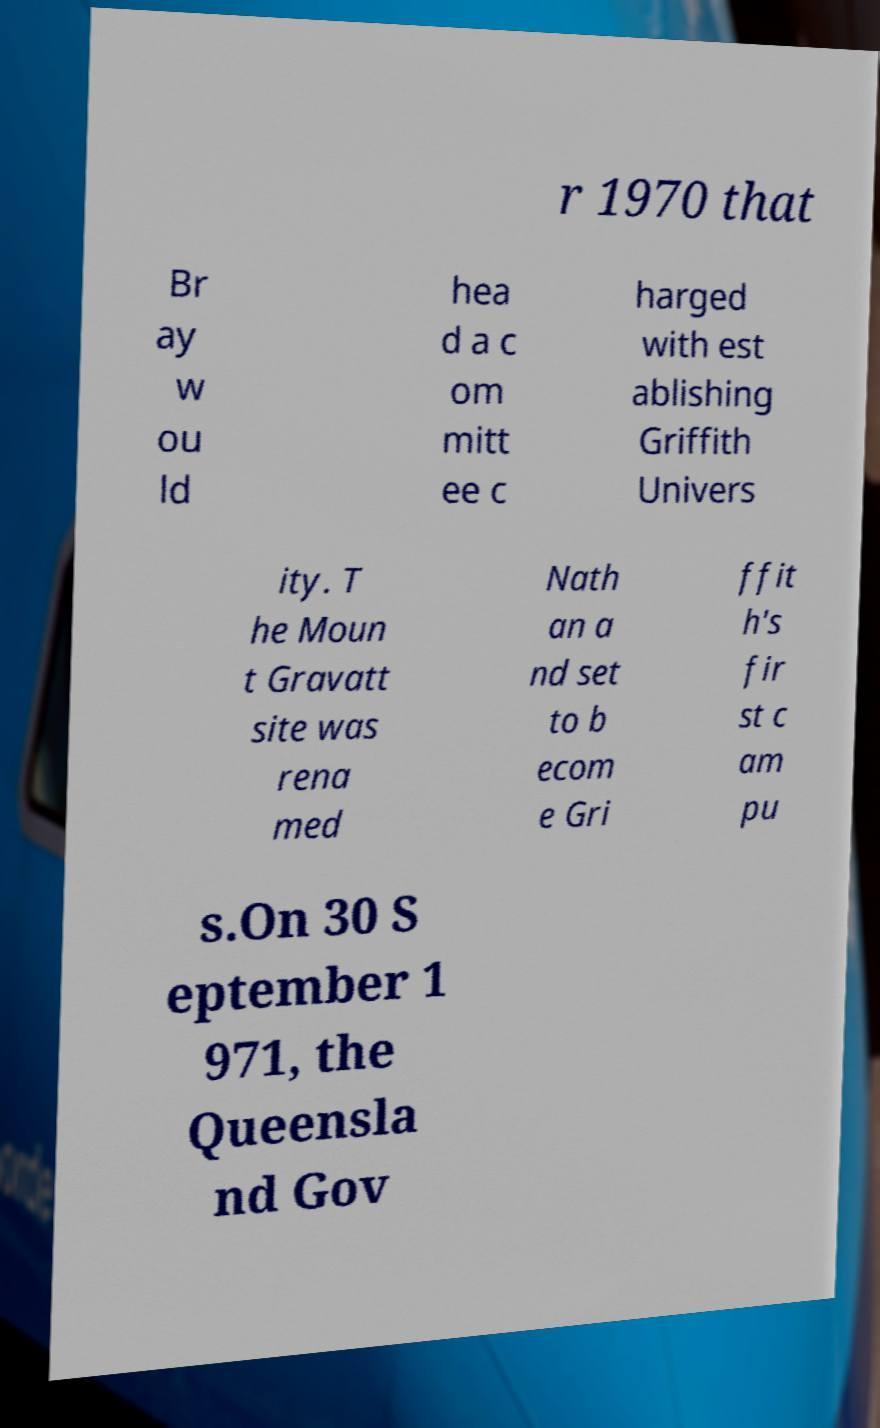Please identify and transcribe the text found in this image. r 1970 that Br ay w ou ld hea d a c om mitt ee c harged with est ablishing Griffith Univers ity. T he Moun t Gravatt site was rena med Nath an a nd set to b ecom e Gri ffit h's fir st c am pu s.On 30 S eptember 1 971, the Queensla nd Gov 